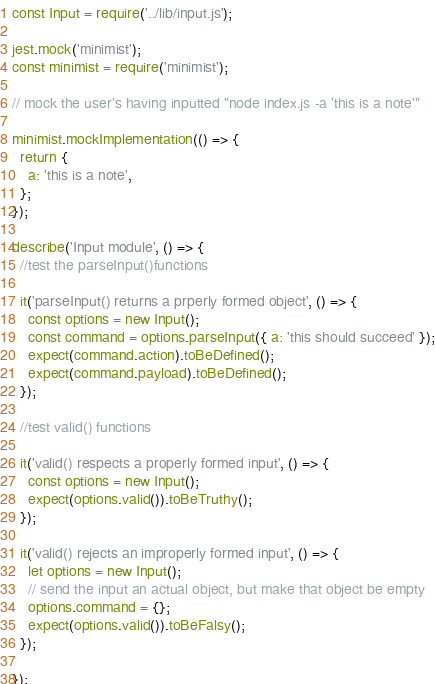<code> <loc_0><loc_0><loc_500><loc_500><_JavaScript_>const Input = require('../lib/input.js');

jest.mock('minimist');
const minimist = require('minimist');

// mock the user's having inputted "node index.js -a 'this is a note'"

minimist.mockImplementation(() => {
  return {
    a: 'this is a note',
  };
});

describe('Input module', () => {
  //test the parseInput()functions

  it('parseInput() returns a prperly formed object', () => {
    const options = new Input();
    const command = options.parseInput({ a: 'this should succeed' });
    expect(command.action).toBeDefined();
    expect(command.payload).toBeDefined();
  });

  //test valid() functions

  it('valid() respects a properly formed input', () => {
    const options = new Input();
    expect(options.valid()).toBeTruthy();
  });

  it('valid() rejects an improperly formed input', () => {
    let options = new Input();
    // send the input an actual object, but make that object be empty
    options.command = {};
    expect(options.valid()).toBeFalsy();
  });

});</code> 